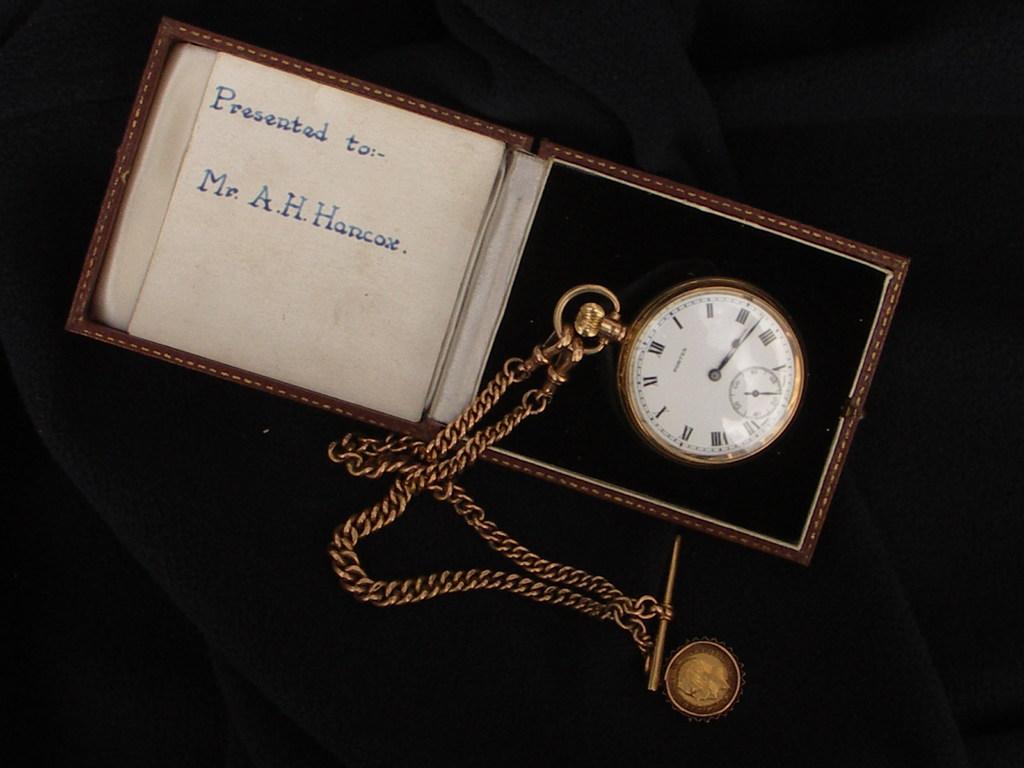Who is the watch presented to?
Your answer should be compact. Mr. a.h. hancox. 